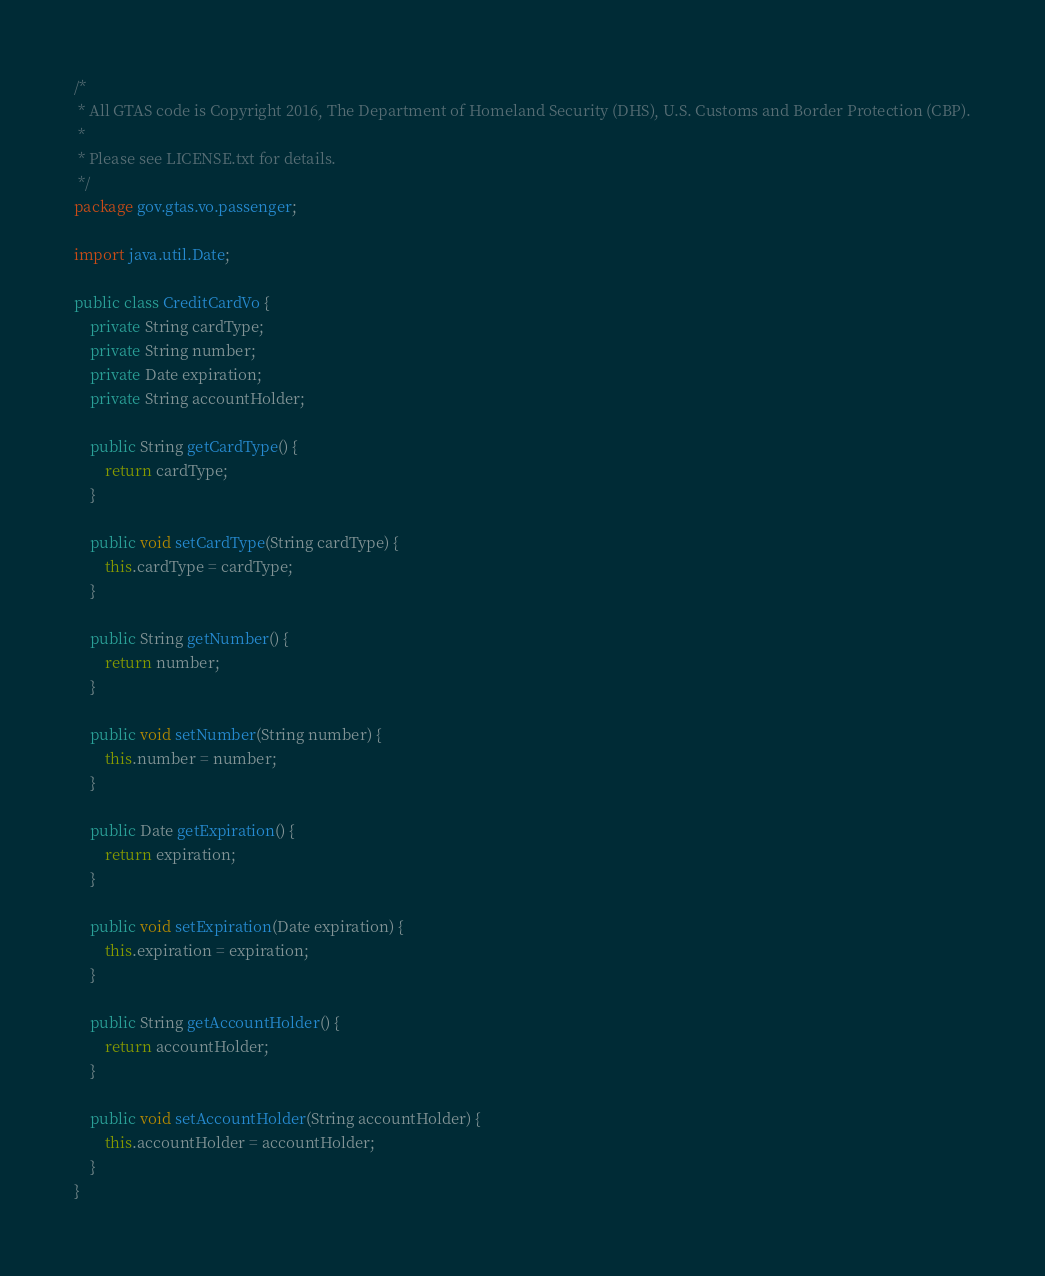<code> <loc_0><loc_0><loc_500><loc_500><_Java_>/*
 * All GTAS code is Copyright 2016, The Department of Homeland Security (DHS), U.S. Customs and Border Protection (CBP).
 * 
 * Please see LICENSE.txt for details.
 */
package gov.gtas.vo.passenger;

import java.util.Date;

public class CreditCardVo {
	private String cardType;
	private String number;
	private Date expiration;
	private String accountHolder;

	public String getCardType() {
		return cardType;
	}

	public void setCardType(String cardType) {
		this.cardType = cardType;
	}

	public String getNumber() {
		return number;
	}

	public void setNumber(String number) {
		this.number = number;
	}

	public Date getExpiration() {
		return expiration;
	}

	public void setExpiration(Date expiration) {
		this.expiration = expiration;
	}

	public String getAccountHolder() {
		return accountHolder;
	}

	public void setAccountHolder(String accountHolder) {
		this.accountHolder = accountHolder;
	}
}
</code> 